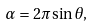<formula> <loc_0><loc_0><loc_500><loc_500>\alpha = 2 \pi \sin \theta ,</formula> 